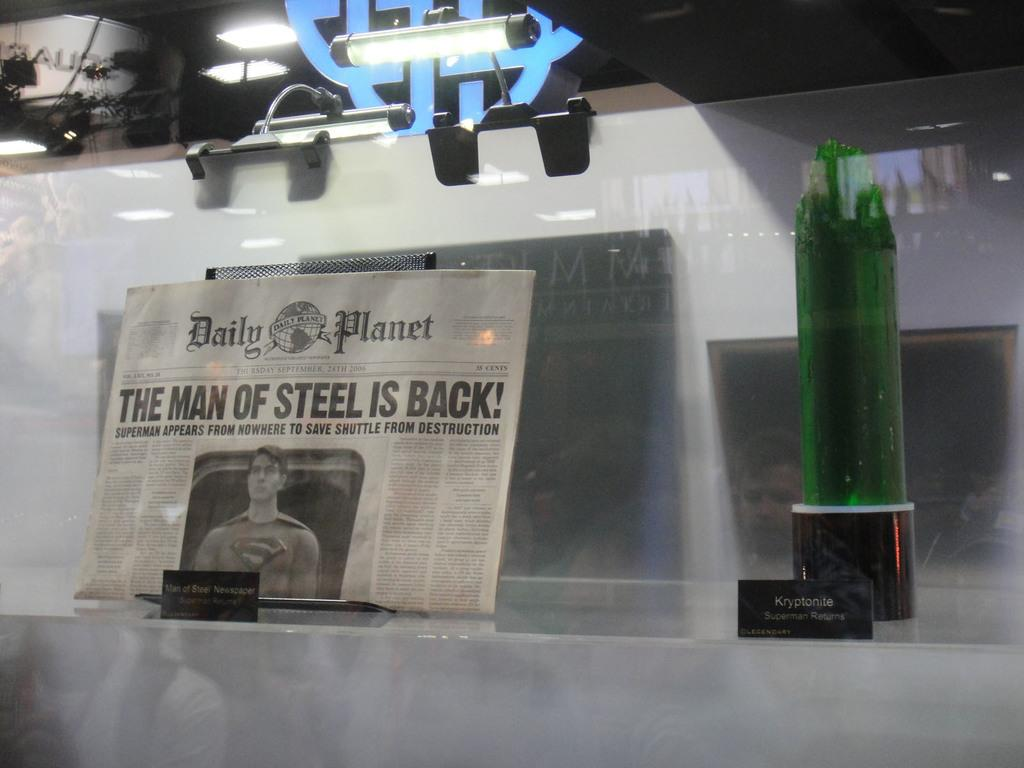<image>
Render a clear and concise summary of the photo. Daily Planet Newspaper that includes the man of steel is back 